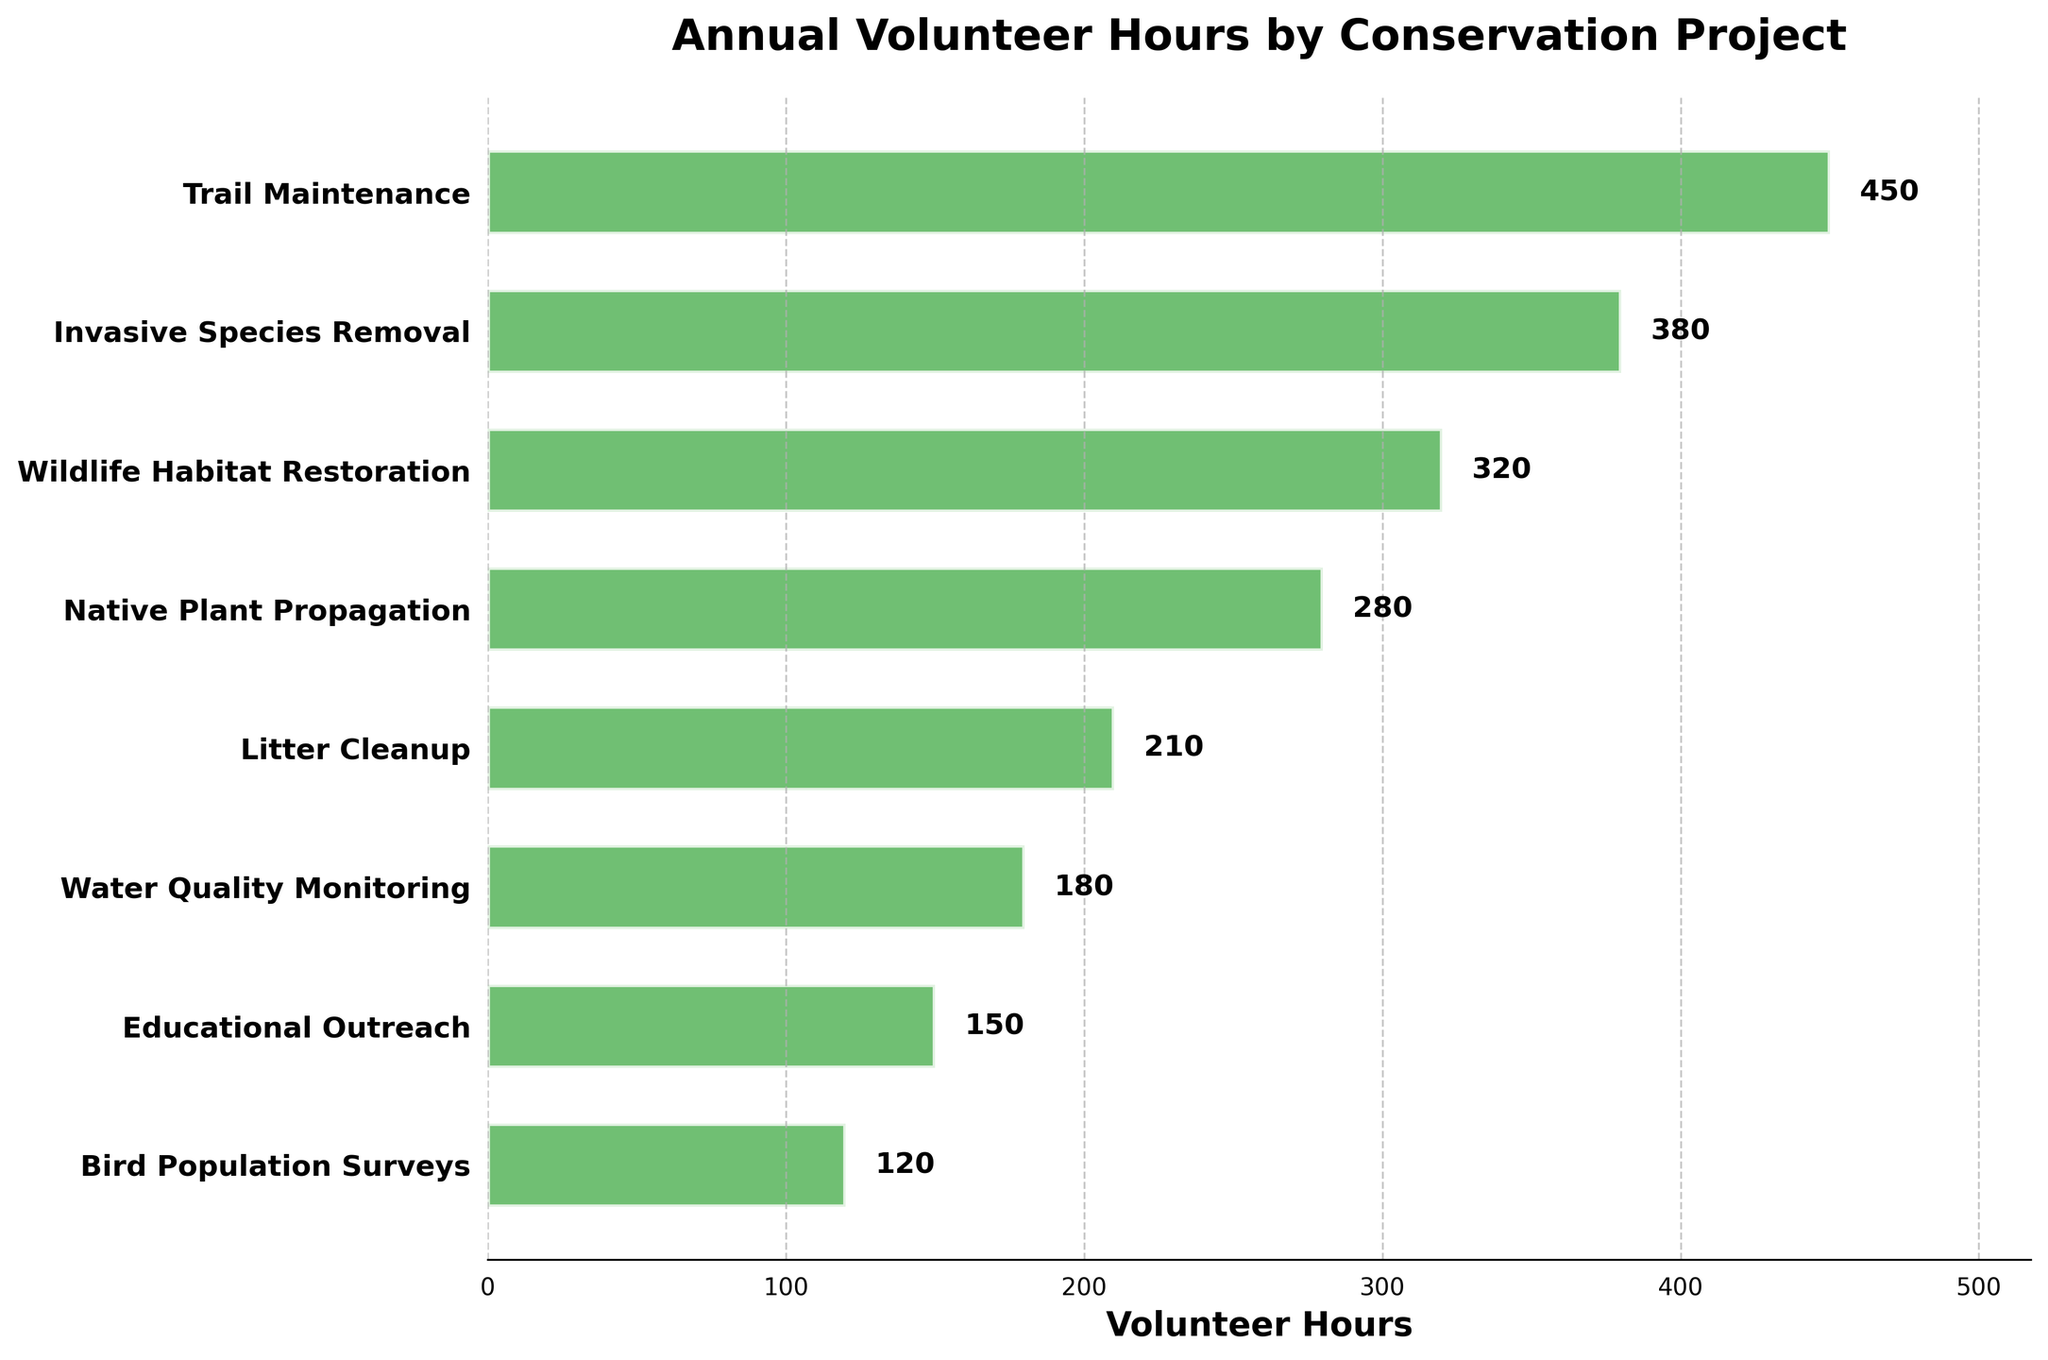what is the title of the plot? The title is displayed at the top of the plot, centered and in bold text: "Annual Volunteer Hours by Conservation Project"
Answer: Annual Volunteer Hours by Conservation Project how many different conservation projects are shown? Count the distinct projects listed on the y-axis of the plot. There are a total of 8 projects displayed: 'Trail Maintenance', 'Invasive Species Removal', 'Wildlife Habitat Restoration', 'Native Plant Propagation', 'Litter Cleanup', 'Water Quality Monitoring', 'Educational Outreach', 'Bird Population Surveys'.
Answer: 8 which project has the highest number of volunteer hours? Identify the project with the longest horizontal bar. The longest bar is for 'Trail Maintenance' with 450 hours.
Answer: Trail Maintenance which project has the lowest number of volunteer hours? Identify the project with the shortest horizontal bar. The shortest bar is for 'Bird Population Surveys' with 120 hours.
Answer: Bird Population Surveys how many volunteer hours are contributed to invasive species removal? Find the bar labeled 'Invasive Species Removal' on the y-axis and read its length. The length corresponds to 380 hours.
Answer: 380 what is the combined volunteer hours for wildlife habitat restoration and native plant propagation? Locate the hours for 'Wildlife Habitat Restoration' (320 hours) and 'Native Plant Propagation' (280 hours), then sum them up: 320 + 280 = 600
Answer: 600 what is the average number of volunteer hours across all projects? Sum all volunteer hours (450 + 380 + 320 + 280 + 210 + 180 + 150 + 120 = 2090) and divide by the number of projects (8): 2090 / 8 = 261.25
Answer: 261.25 are there more volunteer hours for litter cleanup or water quality monitoring? Compare the lengths of the bars for 'Litter Cleanup' (210 hours) and 'Water Quality Monitoring' (180 hours). Since 210 is greater than 180, 'Litter Cleanup' has more volunteer hours.
Answer: Litter Cleanup what percentage of the total volunteer hours is spent on trail maintenance? Find the volunteer hours for 'Trail Maintenance' (450 hours) and calculate the total hours (2090 hours). Then, divide the trail maintenance hours by the total and multiply by 100: (450 / 2090) * 100 ≈ 21.53%
Answer: 21.53 how many projects have fewer than 200 volunteer hours? Identify the bars with a length less than 200 hours. There are three such projects: 'Water Quality Monitoring' (180 hours), 'Educational Outreach' (150 hours), and 'Bird Population Surveys' (120 hours).
Answer: 3 